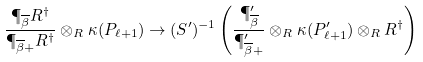Convert formula to latex. <formula><loc_0><loc_0><loc_500><loc_500>\frac { \P _ { \overline { \beta } } R ^ { \dag } } { \P _ { \overline { \beta } + } R ^ { \dag } } \otimes _ { R } \kappa ( P _ { \ell + 1 } ) \rightarrow ( S ^ { \prime } ) ^ { - 1 } \left ( \frac { \P ^ { \prime } _ { \overline { \beta } } } { \P ^ { \prime } _ { \overline { \beta } + } } \otimes _ { R } \kappa ( P ^ { \prime } _ { \ell + 1 } ) \otimes _ { R } R ^ { \dag } \right )</formula> 